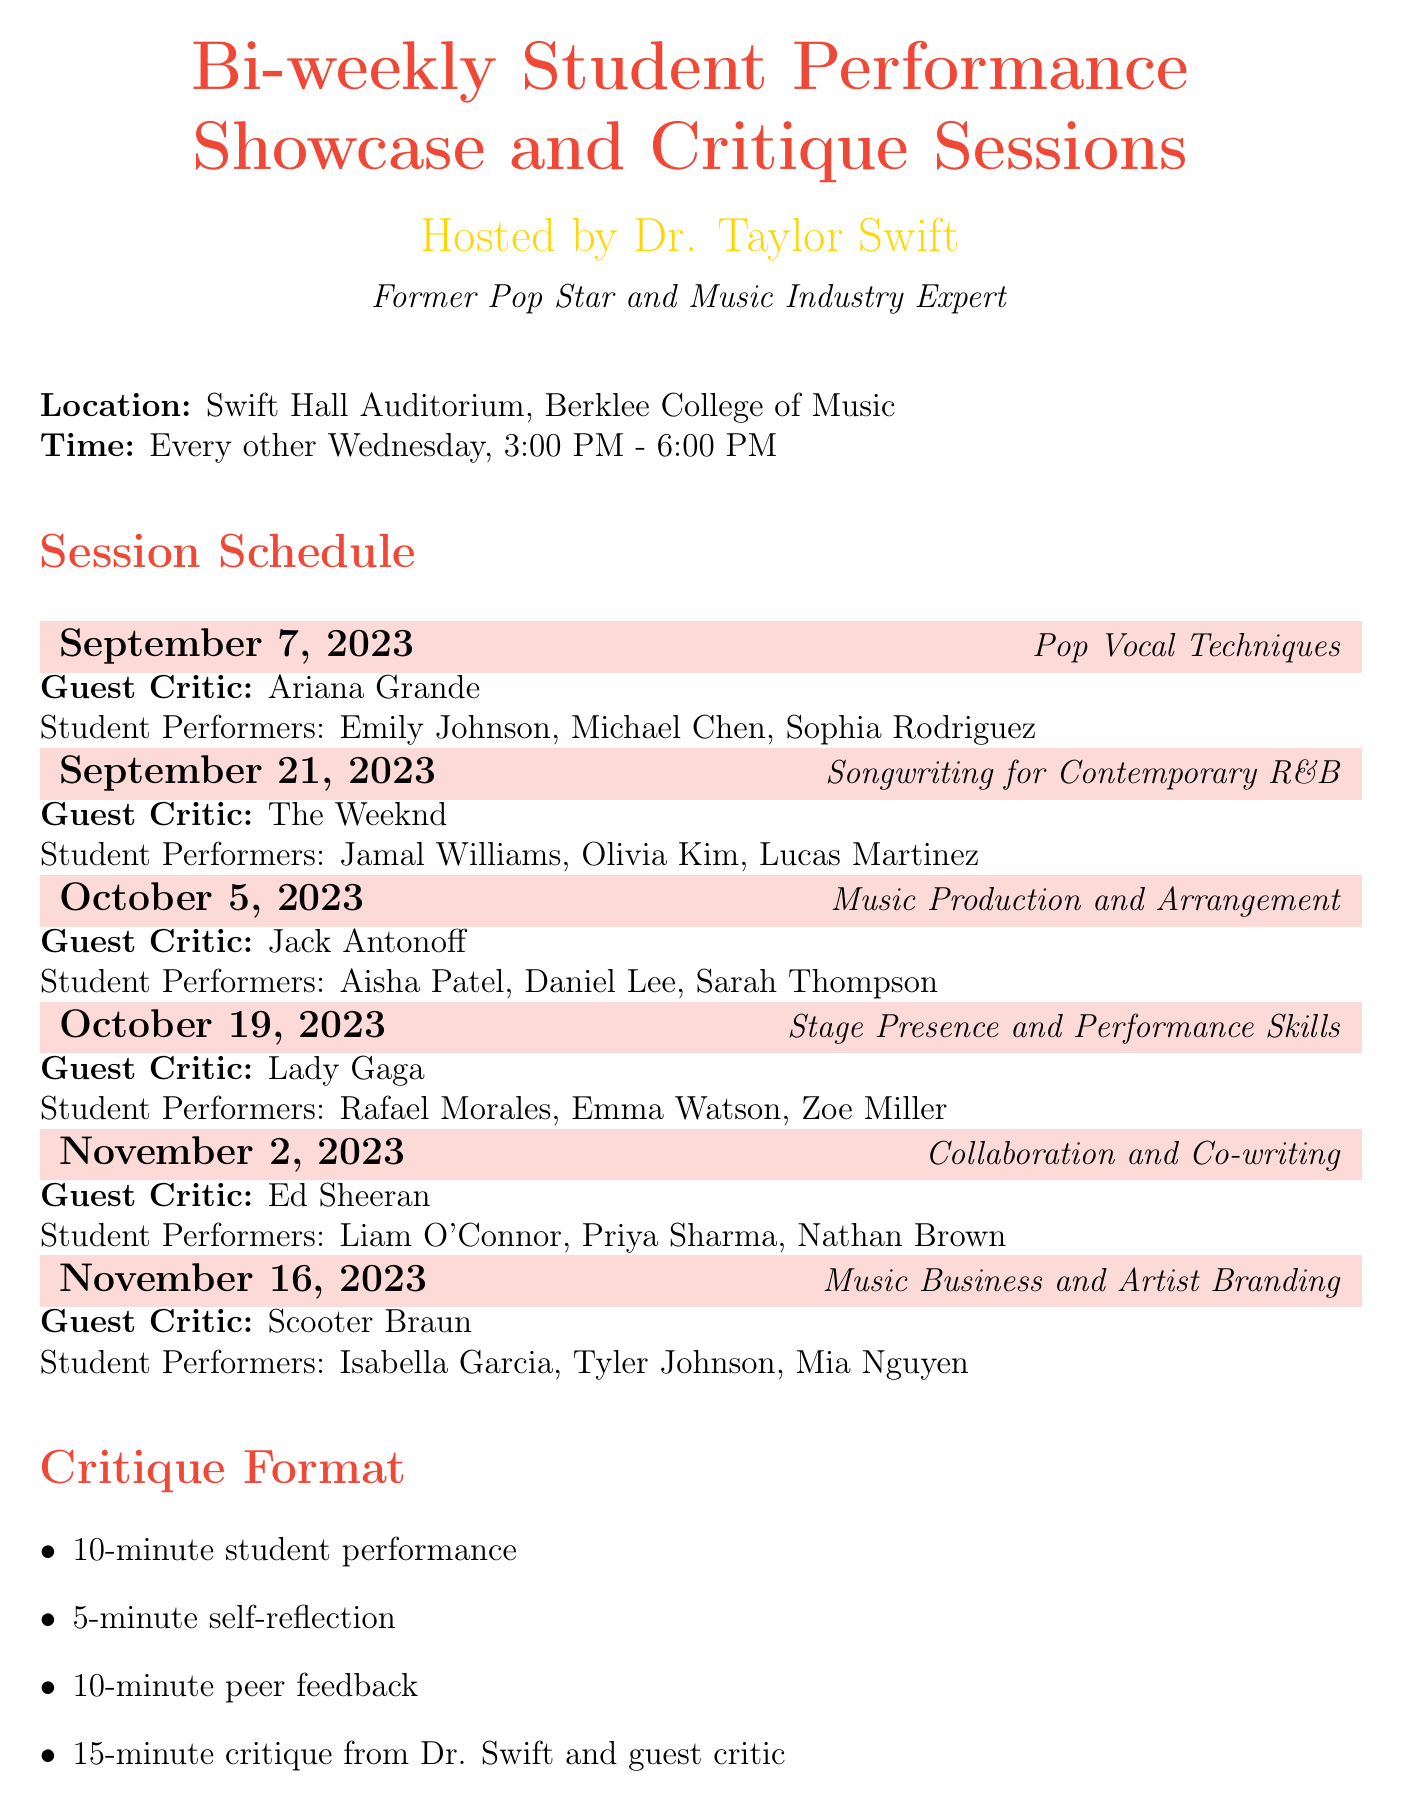What is the schedule title? The title of the document is explicitly given at the beginning, which is "Bi-weekly Student Performance Showcase and Critique Sessions".
Answer: Bi-weekly Student Performance Showcase and Critique Sessions Who is the host of the sessions? The document specifies that the host is Dr. Taylor Swift, including her background as a former pop star and music industry expert.
Answer: Dr. Taylor Swift What is the location of the sessions? The location is explicitly stated in the document as Swift Hall Auditorium, Berklee College of Music.
Answer: Swift Hall Auditorium, Berklee College of Music How often do the sessions occur? The frequency of the sessions is indicated in the document as occurring every other Wednesday.
Answer: Every other Wednesday Name one guest critic for the session on October 5, 2023. The document lists guest critics for each session, providing the name for October 5 as Jack Antonoff.
Answer: Jack Antonoff What is the duration of the self-reflection segment during a session? The document outlines the critique format, specifying that the self-reflection segment lasts for 5 minutes.
Answer: 5-minute List one expected outcome from the sessions. The expected outcomes are listed; one example is improved performance skills.
Answer: Improved performance skills What is one of the evaluation criteria mentioned in the document? The document provides several evaluation criteria; one of them is vocal technique and control.
Answer: Vocal technique and control What type of additional activity is included? The document mentions various additional activities such as networking sessions, one example being a networking session with industry professionals.
Answer: Networking session with industry professionals How long is the student performance segment? According to the critique format outlined in the document, the student performance segment lasts for 10 minutes.
Answer: 10-minute 